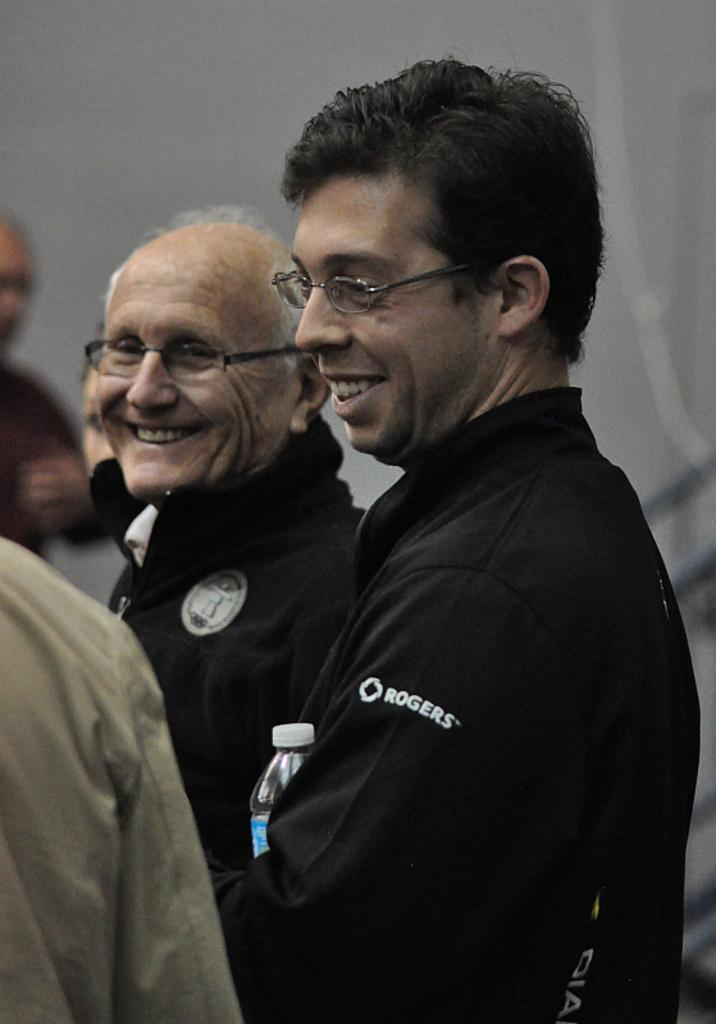How many people are in the image? There are two persons in the image. Where are the persons located in the image? The persons are in the middle of the image. What color are the coats worn by the persons? The persons are wearing black color coats. What accessory are the persons wearing on their faces? The persons are wearing spectacles. What type of animals can be seen at the zoo in the image? There is no zoo or animals present in the image; it features two persons wearing black coats and spectacles. What kind of teeth can be seen in the image? There are no teeth visible in the image, as it features two persons wearing black coats and spectacles. 